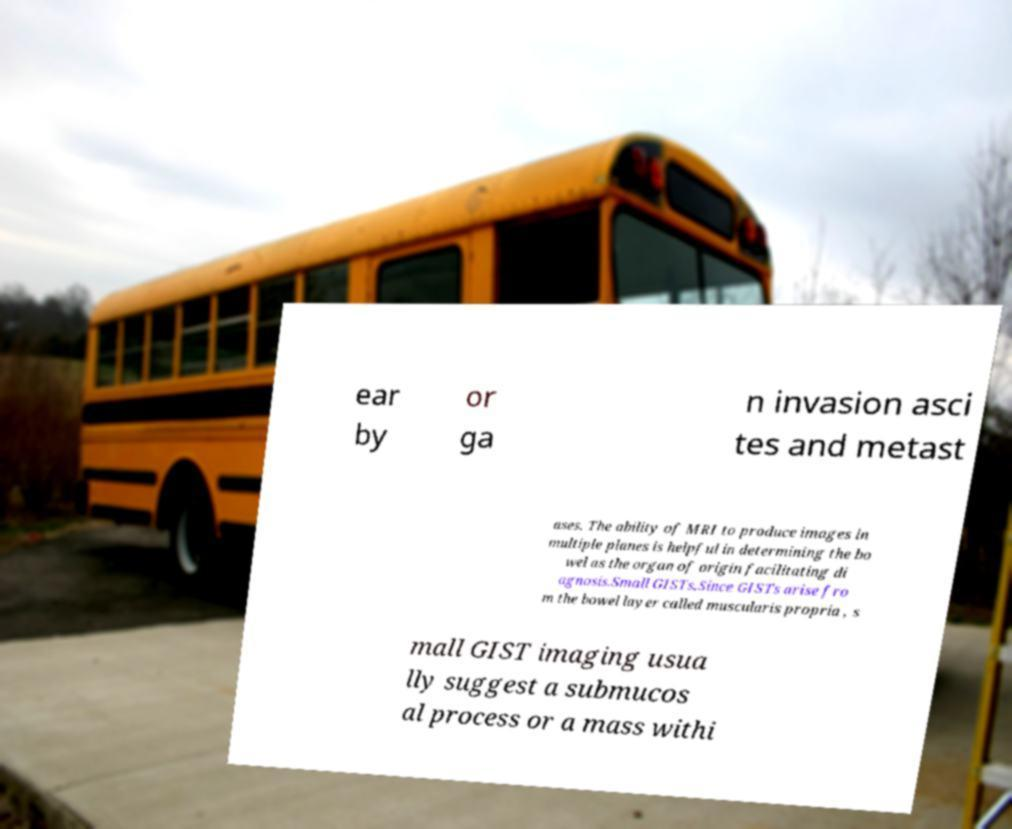What messages or text are displayed in this image? I need them in a readable, typed format. ear by or ga n invasion asci tes and metast ases. The ability of MRI to produce images in multiple planes is helpful in determining the bo wel as the organ of origin facilitating di agnosis.Small GISTs.Since GISTs arise fro m the bowel layer called muscularis propria , s mall GIST imaging usua lly suggest a submucos al process or a mass withi 